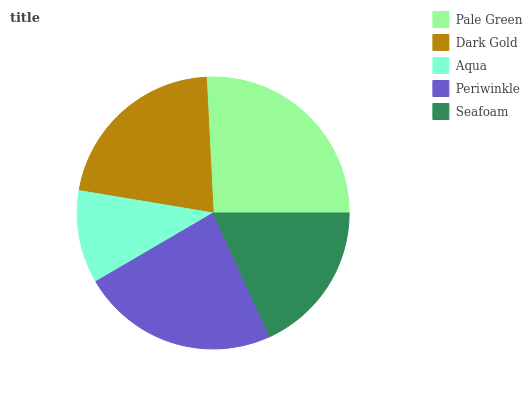Is Aqua the minimum?
Answer yes or no. Yes. Is Pale Green the maximum?
Answer yes or no. Yes. Is Dark Gold the minimum?
Answer yes or no. No. Is Dark Gold the maximum?
Answer yes or no. No. Is Pale Green greater than Dark Gold?
Answer yes or no. Yes. Is Dark Gold less than Pale Green?
Answer yes or no. Yes. Is Dark Gold greater than Pale Green?
Answer yes or no. No. Is Pale Green less than Dark Gold?
Answer yes or no. No. Is Dark Gold the high median?
Answer yes or no. Yes. Is Dark Gold the low median?
Answer yes or no. Yes. Is Pale Green the high median?
Answer yes or no. No. Is Seafoam the low median?
Answer yes or no. No. 